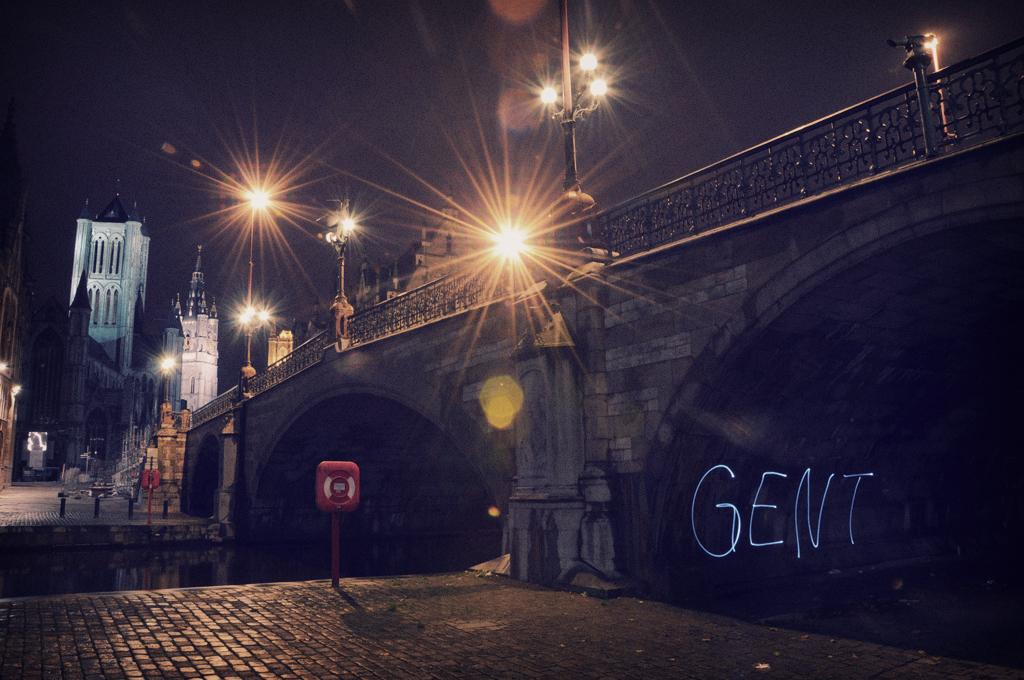What structure can be seen in the right corner of the image? There is a bridge in the right corner of the image. What is under the bridge? There is water under the bridge. What else can be seen in the left corner of the image? There are other buildings in the left corner of the image. What type of amusement can be seen in the image? There is no amusement present in the image; it features a bridge, water, and other buildings. How many dimes are visible on the bridge in the image? There are no dimes visible on the bridge in the image. 